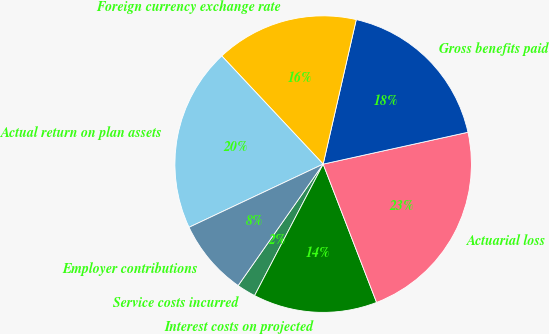Convert chart to OTSL. <chart><loc_0><loc_0><loc_500><loc_500><pie_chart><fcel>Service costs incurred<fcel>Interest costs on projected<fcel>Actuarial loss<fcel>Gross benefits paid<fcel>Foreign currency exchange rate<fcel>Actual return on plan assets<fcel>Employer contributions<nl><fcel>2.07%<fcel>13.52%<fcel>22.58%<fcel>17.97%<fcel>15.57%<fcel>20.02%<fcel>8.27%<nl></chart> 